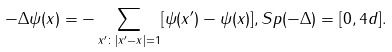<formula> <loc_0><loc_0><loc_500><loc_500>- \Delta \psi ( x ) = - \sum _ { x ^ { \prime } \colon | x ^ { \prime } - x | = 1 } [ \psi ( x ^ { \prime } ) - \psi ( x ) ] , S p ( - \Delta ) = [ 0 , 4 d ] .</formula> 